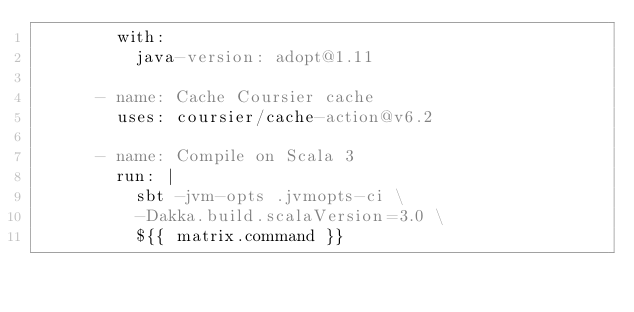<code> <loc_0><loc_0><loc_500><loc_500><_YAML_>        with:
          java-version: adopt@1.11

      - name: Cache Coursier cache
        uses: coursier/cache-action@v6.2

      - name: Compile on Scala 3
        run: |
          sbt -jvm-opts .jvmopts-ci \
          -Dakka.build.scalaVersion=3.0 \
          ${{ matrix.command }}
</code> 